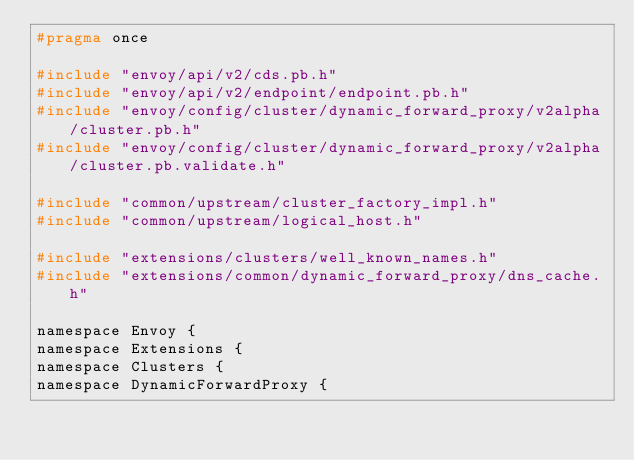Convert code to text. <code><loc_0><loc_0><loc_500><loc_500><_C_>#pragma once

#include "envoy/api/v2/cds.pb.h"
#include "envoy/api/v2/endpoint/endpoint.pb.h"
#include "envoy/config/cluster/dynamic_forward_proxy/v2alpha/cluster.pb.h"
#include "envoy/config/cluster/dynamic_forward_proxy/v2alpha/cluster.pb.validate.h"

#include "common/upstream/cluster_factory_impl.h"
#include "common/upstream/logical_host.h"

#include "extensions/clusters/well_known_names.h"
#include "extensions/common/dynamic_forward_proxy/dns_cache.h"

namespace Envoy {
namespace Extensions {
namespace Clusters {
namespace DynamicForwardProxy {
</code> 